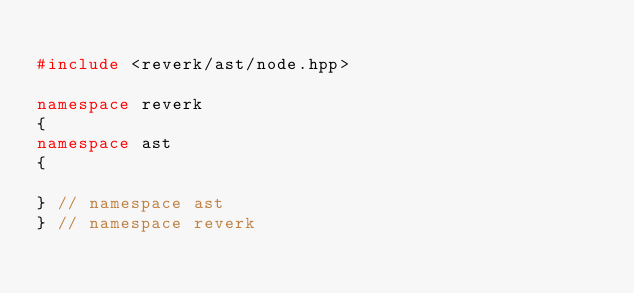Convert code to text. <code><loc_0><loc_0><loc_500><loc_500><_C++_>
#include <reverk/ast/node.hpp>

namespace reverk
{
namespace ast
{

} // namespace ast
} // namespace reverk</code> 